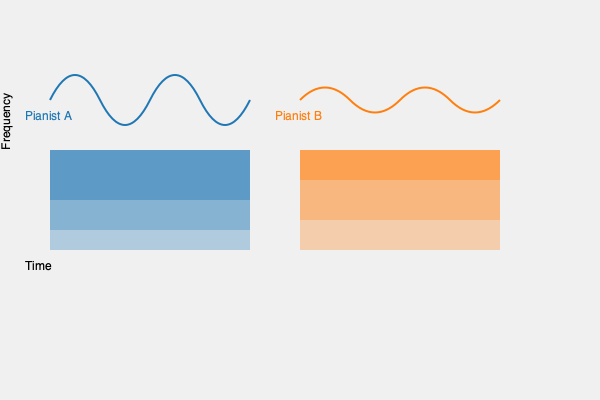Based on the waveform and spectrogram visualizations provided for two pianists performing the same piece, analyze the differences in their interpretations. How might these differences affect the overall emotional impact and technical execution of the performance? To analyze the differences between the two pianists' performances, we'll examine both the waveform and spectrogram visualizations:

1. Waveform analysis:
   a. Pianist A's waveform shows more consistent amplitude with smoother curves, suggesting a more controlled and even touch.
   b. Pianist B's waveform has sharper peaks and valleys, indicating more dynamic contrast and potentially more aggressive articulation.

2. Spectrogram analysis:
   a. Pianist A's spectrogram shows stronger lower frequencies (larger area in the lower part) and a gradual decrease in higher frequencies.
   b. Pianist B's spectrogram displays more energy in the mid-range frequencies and a more even distribution across the frequency spectrum.

3. Emotional impact:
   a. Pianist A's performance likely conveys a sense of smoothness, control, and potentially a more lyrical or romantic interpretation.
   b. Pianist B's performance may come across as more dramatic, with greater dynamic range and possibly a more assertive or passionate approach.

4. Technical execution:
   a. Pianist A seems to focus on evenness and consistency, which may indicate a more refined touch and careful pedaling.
   b. Pianist B appears to emphasize contrast and articulation, potentially showcasing more varied techniques and a wider range of tonal colors.

5. Overall interpretation:
   a. Pianist A's approach might be more suitable for pieces requiring subtlety and nuance, such as Chopin nocturnes or Debussy preludes.
   b. Pianist B's style could be more effective for virtuosic or emotionally intense works, like Liszt's etudes or Beethoven's later sonatas.

The differences in these performances demonstrate how individual artists can bring unique perspectives to the same piece, highlighting various aspects of the music through their technical choices and emotional interpretations.
Answer: Pianist A shows smoother, more controlled playing with emphasis on lower frequencies, while Pianist B demonstrates greater dynamic contrast and mid-range emphasis, resulting in different emotional impacts and technical approaches to the piece. 